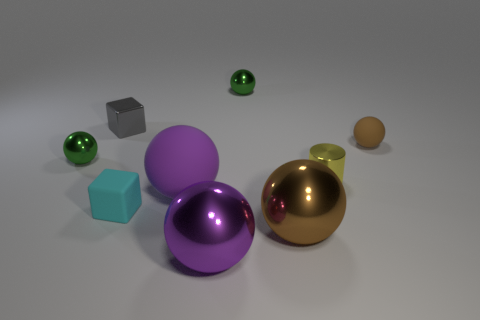What number of small green things have the same material as the gray cube?
Make the answer very short. 2. What is the shape of the object that is the same color as the large rubber sphere?
Provide a succinct answer. Sphere. Does the object behind the gray shiny thing have the same shape as the small brown thing?
Provide a succinct answer. Yes. What color is the tiny cube that is the same material as the tiny cylinder?
Your answer should be very brief. Gray. There is a cube in front of the gray block that is behind the cyan object; is there a cyan matte cube behind it?
Ensure brevity in your answer.  No. What shape is the brown metallic object?
Provide a short and direct response. Sphere. Is the number of gray objects that are to the right of the small yellow metal cylinder less than the number of small yellow cylinders?
Offer a very short reply. Yes. Are there any tiny cyan matte objects that have the same shape as the brown matte thing?
Keep it short and to the point. No. What is the shape of the metallic object that is the same size as the brown shiny ball?
Make the answer very short. Sphere. How many things are either cyan cylinders or small shiny objects?
Offer a terse response. 4. 